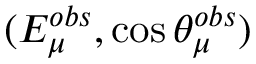Convert formula to latex. <formula><loc_0><loc_0><loc_500><loc_500>( E _ { \mu } ^ { o b s } , \cos \theta _ { \mu } ^ { o b s } )</formula> 